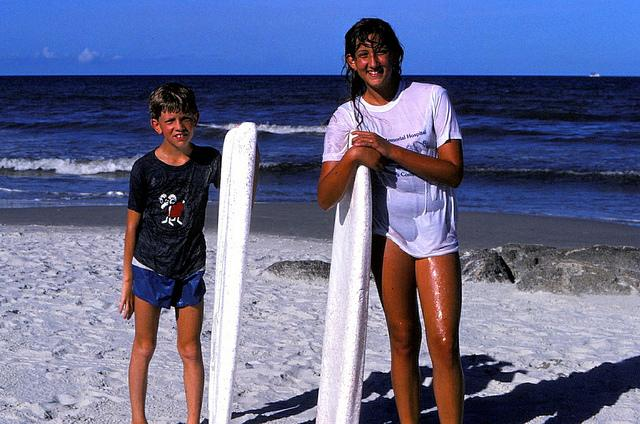How do these people know each other? siblings 